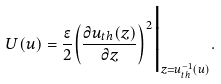<formula> <loc_0><loc_0><loc_500><loc_500>U ( u ) = \frac { \epsilon } { 2 } { \left ( { \frac { \partial u _ { t h } ( z ) } { \partial z } } \right ) } ^ { 2 } \Big | _ { z = u _ { t h } ^ { - 1 } ( u ) } .</formula> 